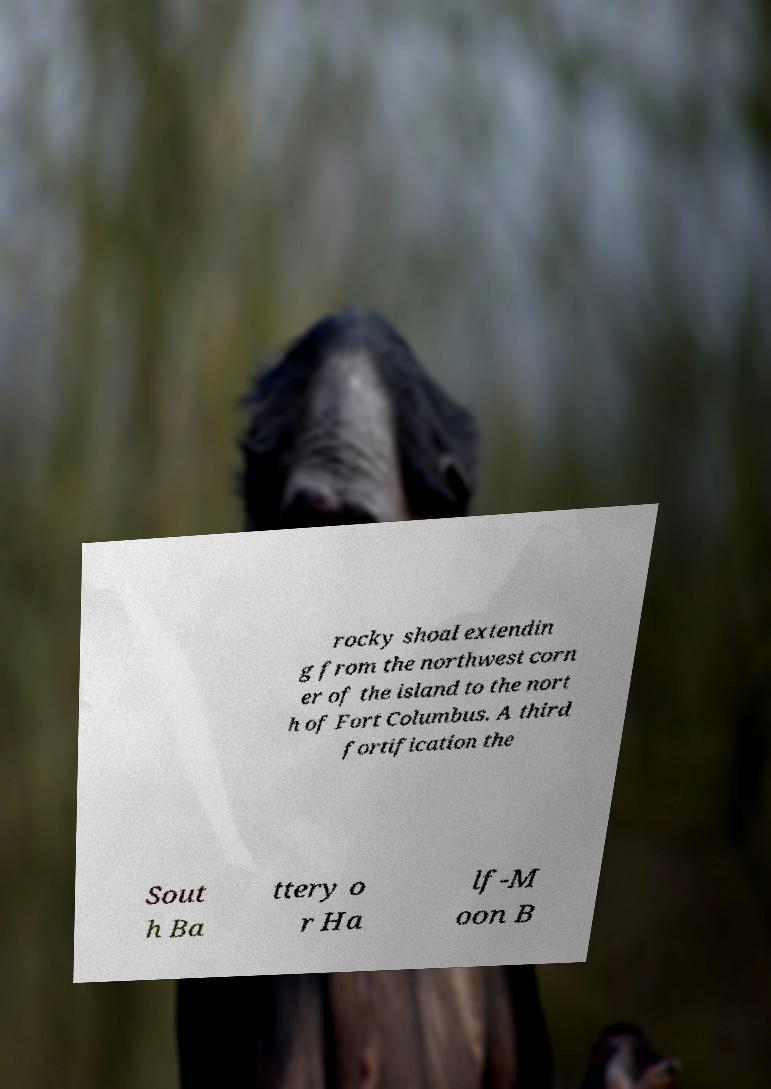What messages or text are displayed in this image? I need them in a readable, typed format. rocky shoal extendin g from the northwest corn er of the island to the nort h of Fort Columbus. A third fortification the Sout h Ba ttery o r Ha lf-M oon B 